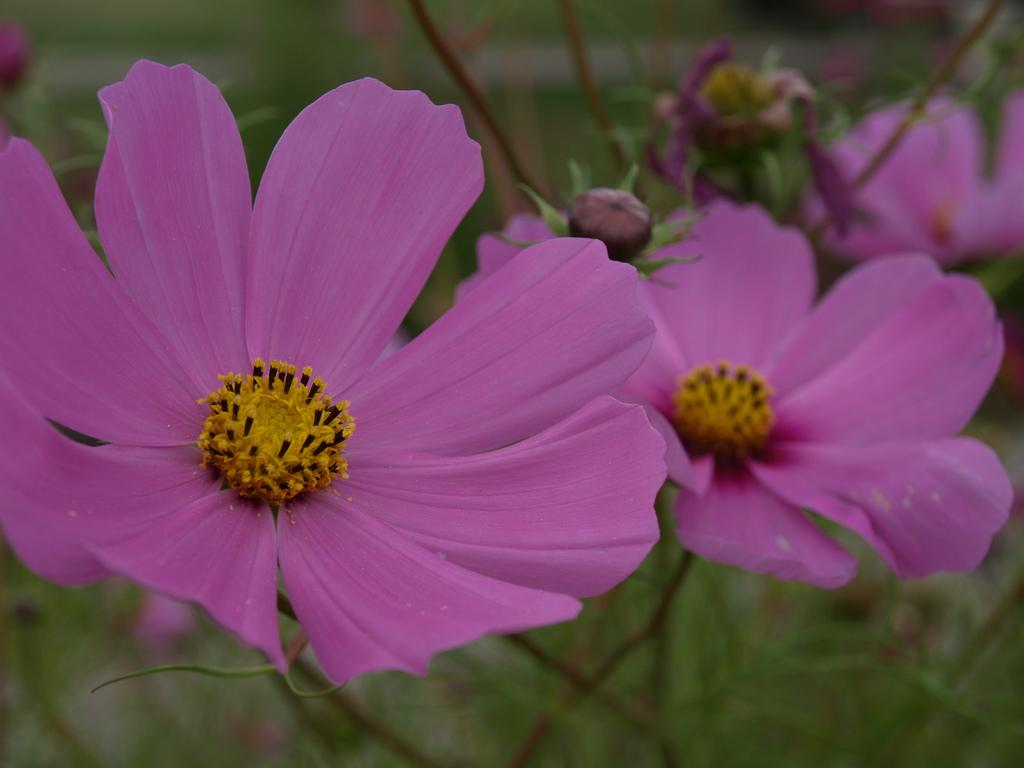What is located in the foreground of the image? There are flowers in the foreground of the image. What can be seen in the background of the image? There are plants in the background of the image. What type of pot is used for the growth of the flowers in the image? There is no pot mentioned or visible in the image; the flowers are directly in the foreground. How does love manifest itself in the image? The image does not depict love or any related emotions; it features flowers and plants. 